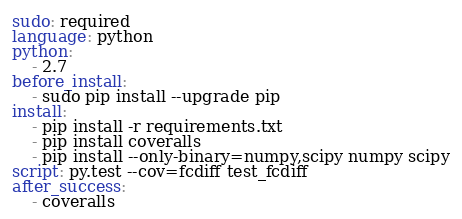Convert code to text. <code><loc_0><loc_0><loc_500><loc_500><_YAML_>sudo: required
language: python
python:
    - 2.7
before_install:
    - sudo pip install --upgrade pip
install:
    - pip install -r requirements.txt
    - pip install coveralls
    - pip install --only-binary=numpy,scipy numpy scipy
script: py.test --cov=fcdiff test_fcdiff
after_success:
    - coveralls
</code> 